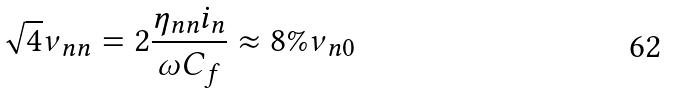<formula> <loc_0><loc_0><loc_500><loc_500>\sqrt { 4 } \nu _ { n n } = 2 \frac { \eta _ { n n } i _ { n } } { \omega C _ { f } } \approx 8 \% \nu _ { n 0 }</formula> 